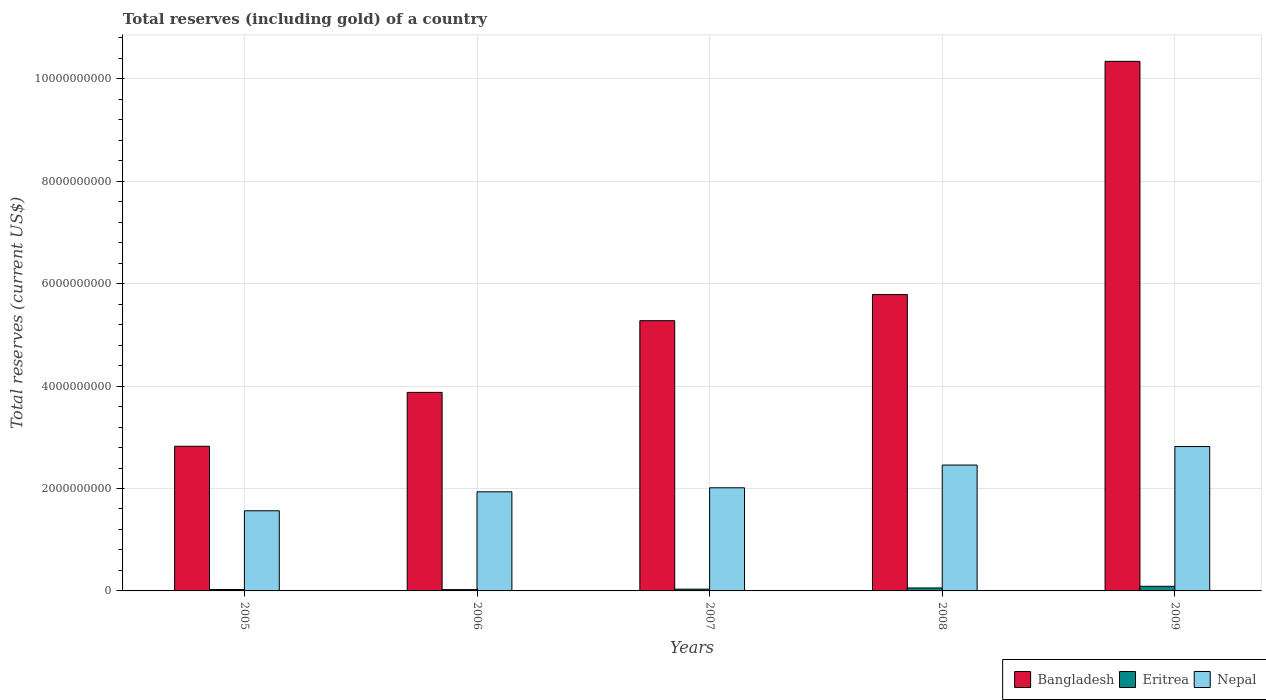How many bars are there on the 5th tick from the left?
Offer a terse response. 3. In how many cases, is the number of bars for a given year not equal to the number of legend labels?
Offer a terse response. 0. What is the total reserves (including gold) in Eritrea in 2005?
Provide a succinct answer. 2.79e+07. Across all years, what is the maximum total reserves (including gold) in Bangladesh?
Your answer should be compact. 1.03e+1. Across all years, what is the minimum total reserves (including gold) in Nepal?
Your answer should be compact. 1.57e+09. In which year was the total reserves (including gold) in Bangladesh minimum?
Your answer should be very brief. 2005. What is the total total reserves (including gold) in Bangladesh in the graph?
Your response must be concise. 2.81e+1. What is the difference between the total reserves (including gold) in Bangladesh in 2006 and that in 2008?
Provide a short and direct response. -1.91e+09. What is the difference between the total reserves (including gold) in Bangladesh in 2007 and the total reserves (including gold) in Eritrea in 2008?
Provide a short and direct response. 5.22e+09. What is the average total reserves (including gold) in Eritrea per year?
Give a very brief answer. 4.71e+07. In the year 2007, what is the difference between the total reserves (including gold) in Bangladesh and total reserves (including gold) in Nepal?
Your response must be concise. 3.26e+09. In how many years, is the total reserves (including gold) in Eritrea greater than 6800000000 US$?
Your answer should be compact. 0. What is the ratio of the total reserves (including gold) in Eritrea in 2006 to that in 2009?
Give a very brief answer. 0.28. Is the total reserves (including gold) in Bangladesh in 2005 less than that in 2008?
Provide a short and direct response. Yes. What is the difference between the highest and the second highest total reserves (including gold) in Bangladesh?
Provide a succinct answer. 4.55e+09. What is the difference between the highest and the lowest total reserves (including gold) in Nepal?
Provide a succinct answer. 1.25e+09. In how many years, is the total reserves (including gold) in Bangladesh greater than the average total reserves (including gold) in Bangladesh taken over all years?
Your answer should be compact. 2. What does the 2nd bar from the left in 2008 represents?
Provide a succinct answer. Eritrea. What does the 2nd bar from the right in 2005 represents?
Provide a succinct answer. Eritrea. How many bars are there?
Provide a short and direct response. 15. Are all the bars in the graph horizontal?
Provide a short and direct response. No. What is the difference between two consecutive major ticks on the Y-axis?
Offer a very short reply. 2.00e+09. Are the values on the major ticks of Y-axis written in scientific E-notation?
Give a very brief answer. No. Does the graph contain grids?
Ensure brevity in your answer.  Yes. How many legend labels are there?
Make the answer very short. 3. What is the title of the graph?
Keep it short and to the point. Total reserves (including gold) of a country. What is the label or title of the X-axis?
Give a very brief answer. Years. What is the label or title of the Y-axis?
Your answer should be very brief. Total reserves (current US$). What is the Total reserves (current US$) in Bangladesh in 2005?
Your response must be concise. 2.83e+09. What is the Total reserves (current US$) in Eritrea in 2005?
Provide a succinct answer. 2.79e+07. What is the Total reserves (current US$) of Nepal in 2005?
Keep it short and to the point. 1.57e+09. What is the Total reserves (current US$) of Bangladesh in 2006?
Offer a terse response. 3.88e+09. What is the Total reserves (current US$) in Eritrea in 2006?
Keep it short and to the point. 2.54e+07. What is the Total reserves (current US$) of Nepal in 2006?
Your response must be concise. 1.94e+09. What is the Total reserves (current US$) in Bangladesh in 2007?
Give a very brief answer. 5.28e+09. What is the Total reserves (current US$) of Eritrea in 2007?
Your answer should be compact. 3.43e+07. What is the Total reserves (current US$) in Nepal in 2007?
Your answer should be compact. 2.01e+09. What is the Total reserves (current US$) in Bangladesh in 2008?
Offer a very short reply. 5.79e+09. What is the Total reserves (current US$) of Eritrea in 2008?
Give a very brief answer. 5.79e+07. What is the Total reserves (current US$) in Nepal in 2008?
Make the answer very short. 2.46e+09. What is the Total reserves (current US$) of Bangladesh in 2009?
Keep it short and to the point. 1.03e+1. What is the Total reserves (current US$) in Eritrea in 2009?
Make the answer very short. 9.00e+07. What is the Total reserves (current US$) in Nepal in 2009?
Keep it short and to the point. 2.82e+09. Across all years, what is the maximum Total reserves (current US$) in Bangladesh?
Offer a very short reply. 1.03e+1. Across all years, what is the maximum Total reserves (current US$) in Eritrea?
Keep it short and to the point. 9.00e+07. Across all years, what is the maximum Total reserves (current US$) of Nepal?
Your response must be concise. 2.82e+09. Across all years, what is the minimum Total reserves (current US$) of Bangladesh?
Your answer should be very brief. 2.83e+09. Across all years, what is the minimum Total reserves (current US$) in Eritrea?
Give a very brief answer. 2.54e+07. Across all years, what is the minimum Total reserves (current US$) in Nepal?
Your response must be concise. 1.57e+09. What is the total Total reserves (current US$) in Bangladesh in the graph?
Make the answer very short. 2.81e+1. What is the total Total reserves (current US$) of Eritrea in the graph?
Offer a very short reply. 2.35e+08. What is the total Total reserves (current US$) of Nepal in the graph?
Your response must be concise. 1.08e+1. What is the difference between the Total reserves (current US$) in Bangladesh in 2005 and that in 2006?
Your answer should be compact. -1.05e+09. What is the difference between the Total reserves (current US$) of Eritrea in 2005 and that in 2006?
Your answer should be very brief. 2.59e+06. What is the difference between the Total reserves (current US$) of Nepal in 2005 and that in 2006?
Your answer should be very brief. -3.70e+08. What is the difference between the Total reserves (current US$) in Bangladesh in 2005 and that in 2007?
Your answer should be very brief. -2.45e+09. What is the difference between the Total reserves (current US$) in Eritrea in 2005 and that in 2007?
Offer a terse response. -6.34e+06. What is the difference between the Total reserves (current US$) of Nepal in 2005 and that in 2007?
Give a very brief answer. -4.49e+08. What is the difference between the Total reserves (current US$) of Bangladesh in 2005 and that in 2008?
Provide a succinct answer. -2.96e+09. What is the difference between the Total reserves (current US$) in Eritrea in 2005 and that in 2008?
Provide a succinct answer. -3.00e+07. What is the difference between the Total reserves (current US$) of Nepal in 2005 and that in 2008?
Make the answer very short. -8.93e+08. What is the difference between the Total reserves (current US$) in Bangladesh in 2005 and that in 2009?
Offer a terse response. -7.52e+09. What is the difference between the Total reserves (current US$) of Eritrea in 2005 and that in 2009?
Offer a terse response. -6.21e+07. What is the difference between the Total reserves (current US$) of Nepal in 2005 and that in 2009?
Offer a very short reply. -1.25e+09. What is the difference between the Total reserves (current US$) of Bangladesh in 2006 and that in 2007?
Give a very brief answer. -1.40e+09. What is the difference between the Total reserves (current US$) in Eritrea in 2006 and that in 2007?
Offer a terse response. -8.93e+06. What is the difference between the Total reserves (current US$) in Nepal in 2006 and that in 2007?
Your response must be concise. -7.85e+07. What is the difference between the Total reserves (current US$) of Bangladesh in 2006 and that in 2008?
Offer a terse response. -1.91e+09. What is the difference between the Total reserves (current US$) of Eritrea in 2006 and that in 2008?
Provide a succinct answer. -3.25e+07. What is the difference between the Total reserves (current US$) of Nepal in 2006 and that in 2008?
Make the answer very short. -5.22e+08. What is the difference between the Total reserves (current US$) of Bangladesh in 2006 and that in 2009?
Provide a succinct answer. -6.46e+09. What is the difference between the Total reserves (current US$) of Eritrea in 2006 and that in 2009?
Offer a very short reply. -6.47e+07. What is the difference between the Total reserves (current US$) in Nepal in 2006 and that in 2009?
Your answer should be compact. -8.84e+08. What is the difference between the Total reserves (current US$) of Bangladesh in 2007 and that in 2008?
Provide a short and direct response. -5.10e+08. What is the difference between the Total reserves (current US$) in Eritrea in 2007 and that in 2008?
Provide a succinct answer. -2.36e+07. What is the difference between the Total reserves (current US$) in Nepal in 2007 and that in 2008?
Give a very brief answer. -4.44e+08. What is the difference between the Total reserves (current US$) of Bangladesh in 2007 and that in 2009?
Your answer should be very brief. -5.06e+09. What is the difference between the Total reserves (current US$) in Eritrea in 2007 and that in 2009?
Ensure brevity in your answer.  -5.57e+07. What is the difference between the Total reserves (current US$) of Nepal in 2007 and that in 2009?
Provide a succinct answer. -8.05e+08. What is the difference between the Total reserves (current US$) in Bangladesh in 2008 and that in 2009?
Ensure brevity in your answer.  -4.55e+09. What is the difference between the Total reserves (current US$) in Eritrea in 2008 and that in 2009?
Make the answer very short. -3.21e+07. What is the difference between the Total reserves (current US$) in Nepal in 2008 and that in 2009?
Ensure brevity in your answer.  -3.62e+08. What is the difference between the Total reserves (current US$) of Bangladesh in 2005 and the Total reserves (current US$) of Eritrea in 2006?
Your answer should be very brief. 2.80e+09. What is the difference between the Total reserves (current US$) in Bangladesh in 2005 and the Total reserves (current US$) in Nepal in 2006?
Provide a succinct answer. 8.90e+08. What is the difference between the Total reserves (current US$) in Eritrea in 2005 and the Total reserves (current US$) in Nepal in 2006?
Your answer should be very brief. -1.91e+09. What is the difference between the Total reserves (current US$) in Bangladesh in 2005 and the Total reserves (current US$) in Eritrea in 2007?
Provide a short and direct response. 2.79e+09. What is the difference between the Total reserves (current US$) in Bangladesh in 2005 and the Total reserves (current US$) in Nepal in 2007?
Make the answer very short. 8.11e+08. What is the difference between the Total reserves (current US$) of Eritrea in 2005 and the Total reserves (current US$) of Nepal in 2007?
Offer a terse response. -1.99e+09. What is the difference between the Total reserves (current US$) of Bangladesh in 2005 and the Total reserves (current US$) of Eritrea in 2008?
Offer a terse response. 2.77e+09. What is the difference between the Total reserves (current US$) of Bangladesh in 2005 and the Total reserves (current US$) of Nepal in 2008?
Offer a very short reply. 3.67e+08. What is the difference between the Total reserves (current US$) in Eritrea in 2005 and the Total reserves (current US$) in Nepal in 2008?
Give a very brief answer. -2.43e+09. What is the difference between the Total reserves (current US$) in Bangladesh in 2005 and the Total reserves (current US$) in Eritrea in 2009?
Your response must be concise. 2.73e+09. What is the difference between the Total reserves (current US$) of Bangladesh in 2005 and the Total reserves (current US$) of Nepal in 2009?
Offer a terse response. 5.54e+06. What is the difference between the Total reserves (current US$) of Eritrea in 2005 and the Total reserves (current US$) of Nepal in 2009?
Provide a short and direct response. -2.79e+09. What is the difference between the Total reserves (current US$) in Bangladesh in 2006 and the Total reserves (current US$) in Eritrea in 2007?
Ensure brevity in your answer.  3.84e+09. What is the difference between the Total reserves (current US$) of Bangladesh in 2006 and the Total reserves (current US$) of Nepal in 2007?
Provide a succinct answer. 1.86e+09. What is the difference between the Total reserves (current US$) of Eritrea in 2006 and the Total reserves (current US$) of Nepal in 2007?
Offer a terse response. -1.99e+09. What is the difference between the Total reserves (current US$) of Bangladesh in 2006 and the Total reserves (current US$) of Eritrea in 2008?
Keep it short and to the point. 3.82e+09. What is the difference between the Total reserves (current US$) of Bangladesh in 2006 and the Total reserves (current US$) of Nepal in 2008?
Provide a succinct answer. 1.42e+09. What is the difference between the Total reserves (current US$) of Eritrea in 2006 and the Total reserves (current US$) of Nepal in 2008?
Give a very brief answer. -2.43e+09. What is the difference between the Total reserves (current US$) of Bangladesh in 2006 and the Total reserves (current US$) of Eritrea in 2009?
Your response must be concise. 3.79e+09. What is the difference between the Total reserves (current US$) of Bangladesh in 2006 and the Total reserves (current US$) of Nepal in 2009?
Keep it short and to the point. 1.06e+09. What is the difference between the Total reserves (current US$) of Eritrea in 2006 and the Total reserves (current US$) of Nepal in 2009?
Offer a terse response. -2.79e+09. What is the difference between the Total reserves (current US$) of Bangladesh in 2007 and the Total reserves (current US$) of Eritrea in 2008?
Provide a short and direct response. 5.22e+09. What is the difference between the Total reserves (current US$) of Bangladesh in 2007 and the Total reserves (current US$) of Nepal in 2008?
Offer a very short reply. 2.82e+09. What is the difference between the Total reserves (current US$) of Eritrea in 2007 and the Total reserves (current US$) of Nepal in 2008?
Provide a succinct answer. -2.42e+09. What is the difference between the Total reserves (current US$) in Bangladesh in 2007 and the Total reserves (current US$) in Eritrea in 2009?
Your answer should be compact. 5.19e+09. What is the difference between the Total reserves (current US$) in Bangladesh in 2007 and the Total reserves (current US$) in Nepal in 2009?
Offer a terse response. 2.46e+09. What is the difference between the Total reserves (current US$) in Eritrea in 2007 and the Total reserves (current US$) in Nepal in 2009?
Offer a terse response. -2.79e+09. What is the difference between the Total reserves (current US$) in Bangladesh in 2008 and the Total reserves (current US$) in Eritrea in 2009?
Your answer should be very brief. 5.70e+09. What is the difference between the Total reserves (current US$) of Bangladesh in 2008 and the Total reserves (current US$) of Nepal in 2009?
Your response must be concise. 2.97e+09. What is the difference between the Total reserves (current US$) of Eritrea in 2008 and the Total reserves (current US$) of Nepal in 2009?
Your answer should be compact. -2.76e+09. What is the average Total reserves (current US$) in Bangladesh per year?
Offer a very short reply. 5.62e+09. What is the average Total reserves (current US$) in Eritrea per year?
Your answer should be very brief. 4.71e+07. What is the average Total reserves (current US$) of Nepal per year?
Provide a short and direct response. 2.16e+09. In the year 2005, what is the difference between the Total reserves (current US$) in Bangladesh and Total reserves (current US$) in Eritrea?
Provide a succinct answer. 2.80e+09. In the year 2005, what is the difference between the Total reserves (current US$) in Bangladesh and Total reserves (current US$) in Nepal?
Provide a short and direct response. 1.26e+09. In the year 2005, what is the difference between the Total reserves (current US$) in Eritrea and Total reserves (current US$) in Nepal?
Your response must be concise. -1.54e+09. In the year 2006, what is the difference between the Total reserves (current US$) of Bangladesh and Total reserves (current US$) of Eritrea?
Give a very brief answer. 3.85e+09. In the year 2006, what is the difference between the Total reserves (current US$) of Bangladesh and Total reserves (current US$) of Nepal?
Make the answer very short. 1.94e+09. In the year 2006, what is the difference between the Total reserves (current US$) in Eritrea and Total reserves (current US$) in Nepal?
Offer a very short reply. -1.91e+09. In the year 2007, what is the difference between the Total reserves (current US$) in Bangladesh and Total reserves (current US$) in Eritrea?
Offer a very short reply. 5.24e+09. In the year 2007, what is the difference between the Total reserves (current US$) in Bangladesh and Total reserves (current US$) in Nepal?
Provide a succinct answer. 3.26e+09. In the year 2007, what is the difference between the Total reserves (current US$) of Eritrea and Total reserves (current US$) of Nepal?
Ensure brevity in your answer.  -1.98e+09. In the year 2008, what is the difference between the Total reserves (current US$) in Bangladesh and Total reserves (current US$) in Eritrea?
Offer a very short reply. 5.73e+09. In the year 2008, what is the difference between the Total reserves (current US$) of Bangladesh and Total reserves (current US$) of Nepal?
Your answer should be compact. 3.33e+09. In the year 2008, what is the difference between the Total reserves (current US$) of Eritrea and Total reserves (current US$) of Nepal?
Your answer should be compact. -2.40e+09. In the year 2009, what is the difference between the Total reserves (current US$) of Bangladesh and Total reserves (current US$) of Eritrea?
Your answer should be compact. 1.03e+1. In the year 2009, what is the difference between the Total reserves (current US$) in Bangladesh and Total reserves (current US$) in Nepal?
Your answer should be compact. 7.52e+09. In the year 2009, what is the difference between the Total reserves (current US$) in Eritrea and Total reserves (current US$) in Nepal?
Give a very brief answer. -2.73e+09. What is the ratio of the Total reserves (current US$) of Bangladesh in 2005 to that in 2006?
Make the answer very short. 0.73. What is the ratio of the Total reserves (current US$) in Eritrea in 2005 to that in 2006?
Your response must be concise. 1.1. What is the ratio of the Total reserves (current US$) of Nepal in 2005 to that in 2006?
Provide a short and direct response. 0.81. What is the ratio of the Total reserves (current US$) of Bangladesh in 2005 to that in 2007?
Provide a succinct answer. 0.54. What is the ratio of the Total reserves (current US$) of Eritrea in 2005 to that in 2007?
Provide a short and direct response. 0.82. What is the ratio of the Total reserves (current US$) of Nepal in 2005 to that in 2007?
Provide a succinct answer. 0.78. What is the ratio of the Total reserves (current US$) of Bangladesh in 2005 to that in 2008?
Provide a short and direct response. 0.49. What is the ratio of the Total reserves (current US$) in Eritrea in 2005 to that in 2008?
Provide a succinct answer. 0.48. What is the ratio of the Total reserves (current US$) of Nepal in 2005 to that in 2008?
Offer a terse response. 0.64. What is the ratio of the Total reserves (current US$) of Bangladesh in 2005 to that in 2009?
Provide a succinct answer. 0.27. What is the ratio of the Total reserves (current US$) in Eritrea in 2005 to that in 2009?
Give a very brief answer. 0.31. What is the ratio of the Total reserves (current US$) in Nepal in 2005 to that in 2009?
Ensure brevity in your answer.  0.56. What is the ratio of the Total reserves (current US$) in Bangladesh in 2006 to that in 2007?
Provide a succinct answer. 0.73. What is the ratio of the Total reserves (current US$) of Eritrea in 2006 to that in 2007?
Your response must be concise. 0.74. What is the ratio of the Total reserves (current US$) in Nepal in 2006 to that in 2007?
Keep it short and to the point. 0.96. What is the ratio of the Total reserves (current US$) in Bangladesh in 2006 to that in 2008?
Ensure brevity in your answer.  0.67. What is the ratio of the Total reserves (current US$) of Eritrea in 2006 to that in 2008?
Provide a succinct answer. 0.44. What is the ratio of the Total reserves (current US$) of Nepal in 2006 to that in 2008?
Offer a terse response. 0.79. What is the ratio of the Total reserves (current US$) in Bangladesh in 2006 to that in 2009?
Your response must be concise. 0.37. What is the ratio of the Total reserves (current US$) in Eritrea in 2006 to that in 2009?
Provide a succinct answer. 0.28. What is the ratio of the Total reserves (current US$) of Nepal in 2006 to that in 2009?
Your response must be concise. 0.69. What is the ratio of the Total reserves (current US$) in Bangladesh in 2007 to that in 2008?
Make the answer very short. 0.91. What is the ratio of the Total reserves (current US$) in Eritrea in 2007 to that in 2008?
Provide a short and direct response. 0.59. What is the ratio of the Total reserves (current US$) in Nepal in 2007 to that in 2008?
Give a very brief answer. 0.82. What is the ratio of the Total reserves (current US$) in Bangladesh in 2007 to that in 2009?
Offer a terse response. 0.51. What is the ratio of the Total reserves (current US$) in Eritrea in 2007 to that in 2009?
Ensure brevity in your answer.  0.38. What is the ratio of the Total reserves (current US$) in Bangladesh in 2008 to that in 2009?
Offer a terse response. 0.56. What is the ratio of the Total reserves (current US$) in Eritrea in 2008 to that in 2009?
Offer a very short reply. 0.64. What is the ratio of the Total reserves (current US$) of Nepal in 2008 to that in 2009?
Offer a terse response. 0.87. What is the difference between the highest and the second highest Total reserves (current US$) in Bangladesh?
Provide a short and direct response. 4.55e+09. What is the difference between the highest and the second highest Total reserves (current US$) of Eritrea?
Provide a short and direct response. 3.21e+07. What is the difference between the highest and the second highest Total reserves (current US$) in Nepal?
Offer a very short reply. 3.62e+08. What is the difference between the highest and the lowest Total reserves (current US$) of Bangladesh?
Keep it short and to the point. 7.52e+09. What is the difference between the highest and the lowest Total reserves (current US$) in Eritrea?
Ensure brevity in your answer.  6.47e+07. What is the difference between the highest and the lowest Total reserves (current US$) of Nepal?
Your answer should be very brief. 1.25e+09. 